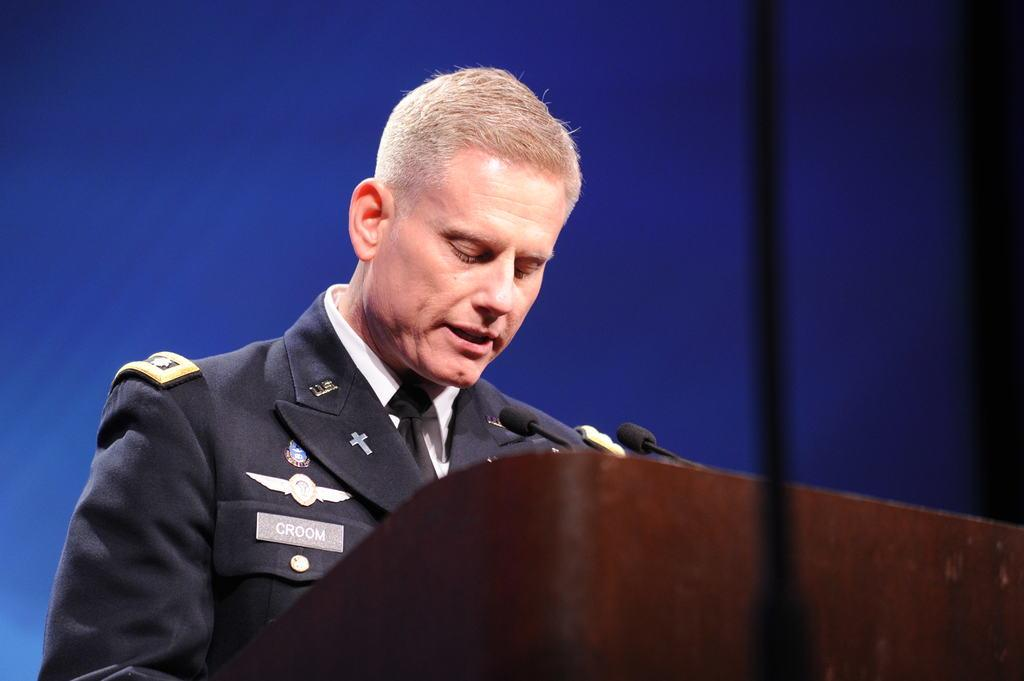What is the main subject of the image? There is a person standing in the image. Are there any animals present in the image? Yes, there are mice in the image. What structure can be seen in the image? There is a podium in the image. What color is the background of the image? The background of the image is blue. Can you describe the crook that the person is holding in the image? There is no crook present in the image; the person is not holding any object. What type of snake can be seen slithering on the podium in the image? There are no snakes present in the image; only mice are mentioned. 